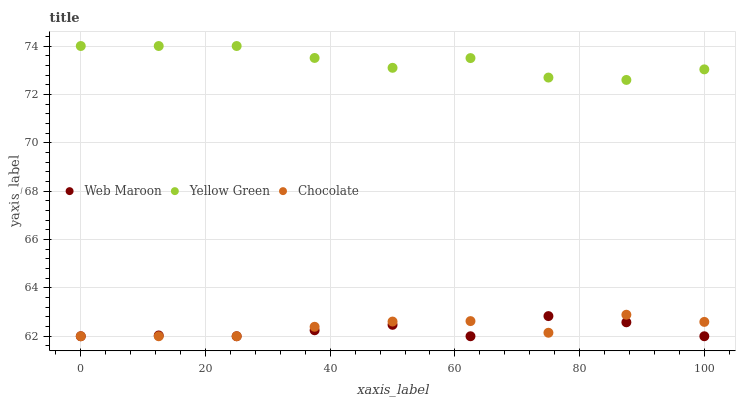Does Web Maroon have the minimum area under the curve?
Answer yes or no. Yes. Does Yellow Green have the maximum area under the curve?
Answer yes or no. Yes. Does Chocolate have the minimum area under the curve?
Answer yes or no. No. Does Chocolate have the maximum area under the curve?
Answer yes or no. No. Is Chocolate the smoothest?
Answer yes or no. Yes. Is Yellow Green the roughest?
Answer yes or no. Yes. Is Yellow Green the smoothest?
Answer yes or no. No. Is Chocolate the roughest?
Answer yes or no. No. Does Web Maroon have the lowest value?
Answer yes or no. Yes. Does Yellow Green have the lowest value?
Answer yes or no. No. Does Yellow Green have the highest value?
Answer yes or no. Yes. Does Chocolate have the highest value?
Answer yes or no. No. Is Chocolate less than Yellow Green?
Answer yes or no. Yes. Is Yellow Green greater than Web Maroon?
Answer yes or no. Yes. Does Web Maroon intersect Chocolate?
Answer yes or no. Yes. Is Web Maroon less than Chocolate?
Answer yes or no. No. Is Web Maroon greater than Chocolate?
Answer yes or no. No. Does Chocolate intersect Yellow Green?
Answer yes or no. No. 